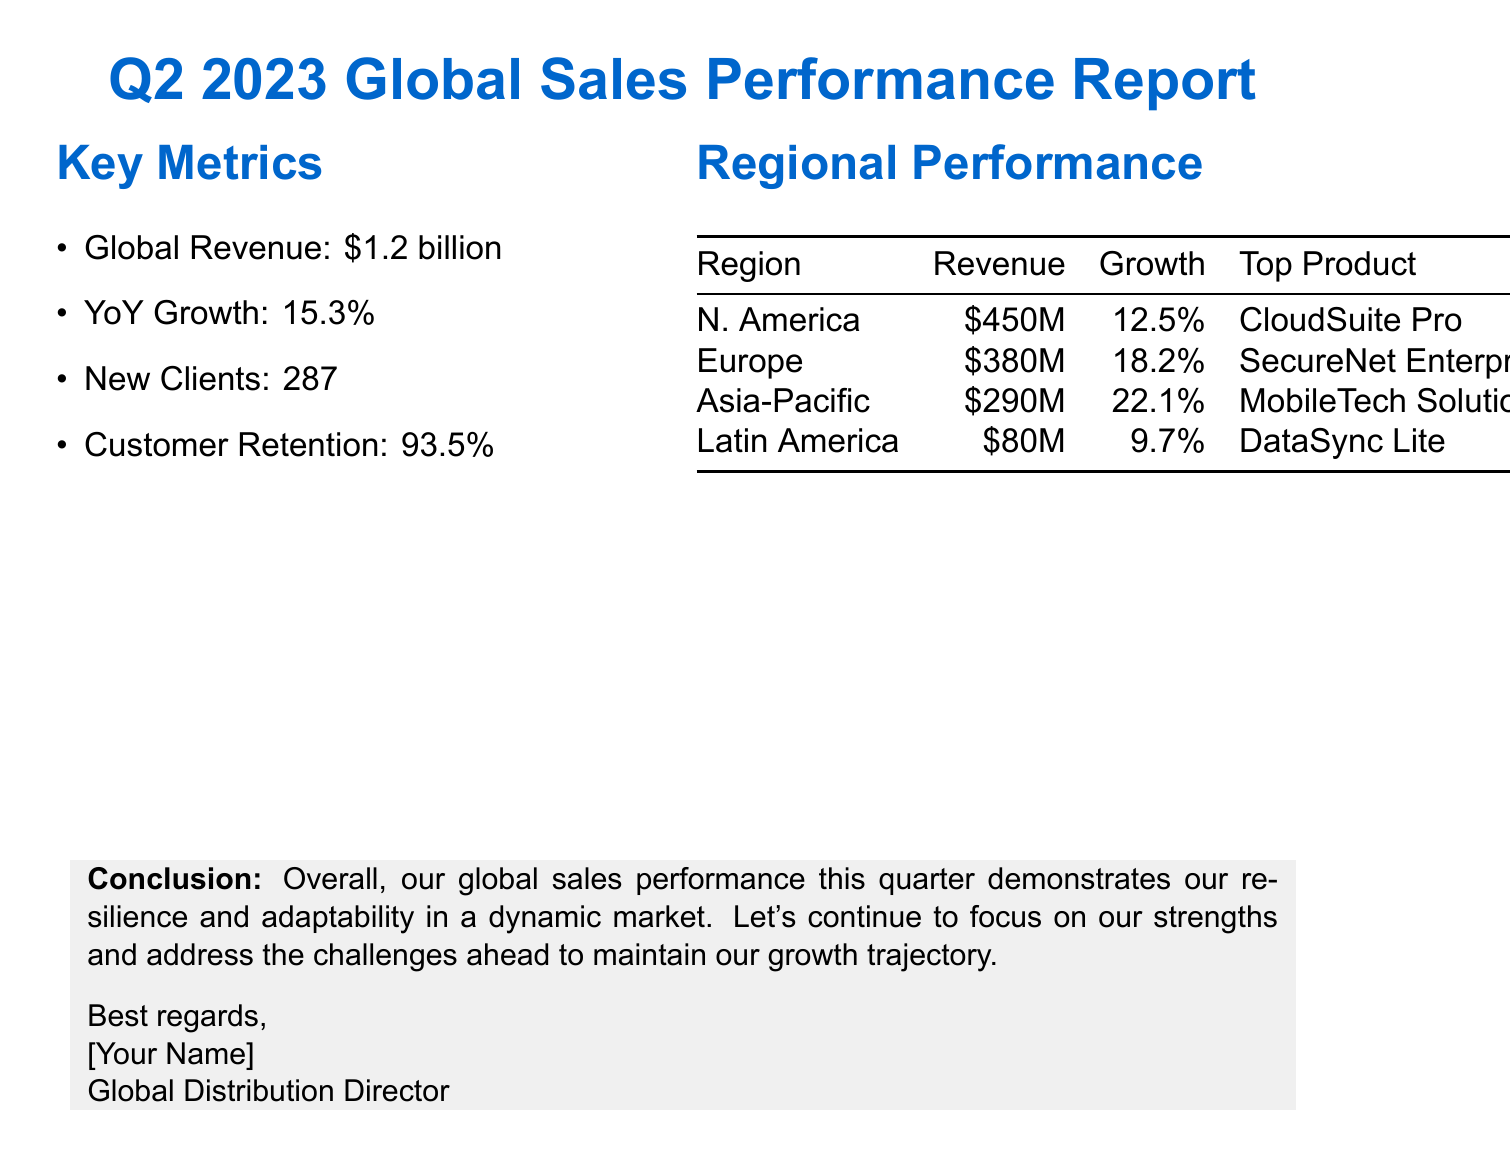What is the total global revenue for Q2 2023? The total global revenue is stated in the key metrics section of the document.
Answer: $1.2 billion What is the year-over-year growth percentage? This information is also found in the key metrics section.
Answer: 15.3% Which region had the highest revenue? The regions are compared in the regional performance section, and North America has the highest revenue.
Answer: North America What is the top product in the Asia-Pacific region? The information about the top products is listed under regional performance.
Answer: MobileTech Solutions What challenge is mentioned regarding the European market? This detail is included in the challenges section, specifically about competition.
Answer: Increased competition What opportunity is associated with Microsoft? The opportunities section includes a strategic partnership with Microsoft.
Answer: Strategic partnership with Microsoft for cloud integration How many new clients were acquired in Q2 2023? The number of new clients is specified in the key metrics portion of the document.
Answer: 287 What is the customer retention rate? The document mentions this metric within the key metrics section.
Answer: 93.5% Which region experienced the most significant growth rate? The growth rates for each region can be compared in the regional performance section.
Answer: Asia-Pacific 